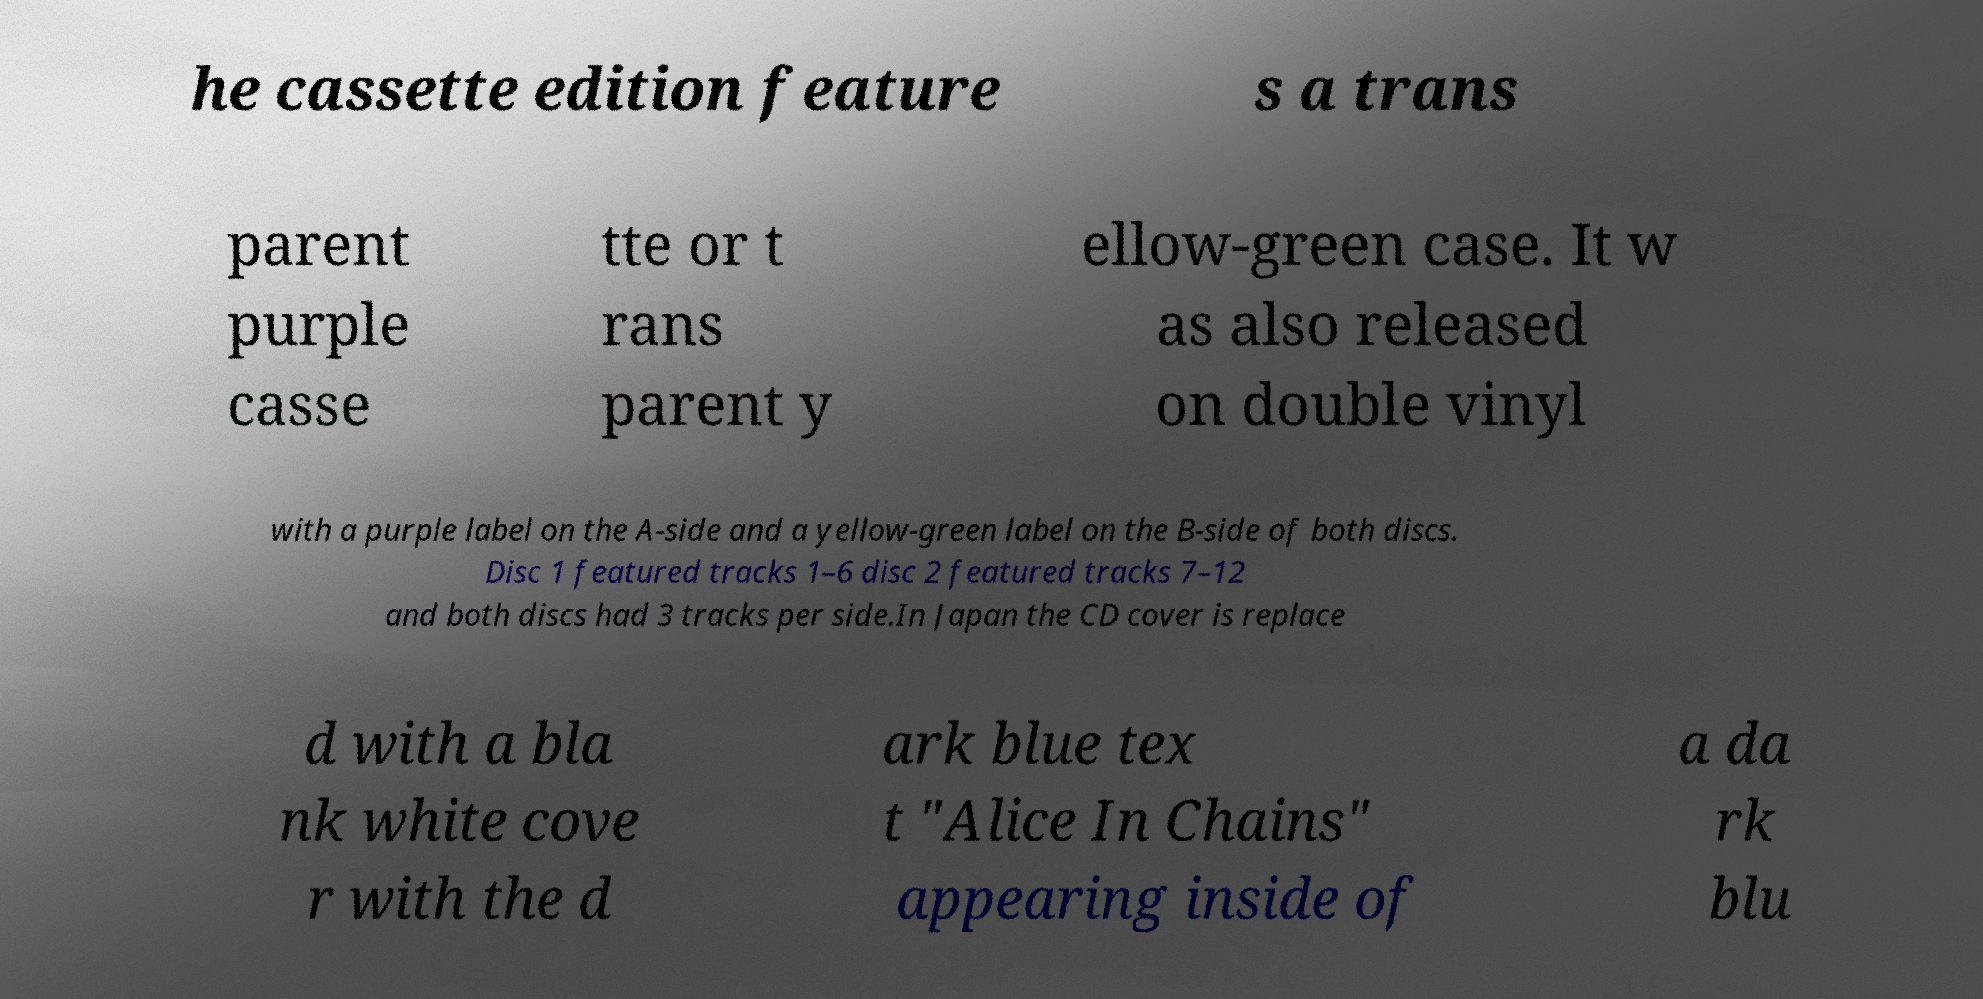Can you accurately transcribe the text from the provided image for me? he cassette edition feature s a trans parent purple casse tte or t rans parent y ellow-green case. It w as also released on double vinyl with a purple label on the A-side and a yellow-green label on the B-side of both discs. Disc 1 featured tracks 1–6 disc 2 featured tracks 7–12 and both discs had 3 tracks per side.In Japan the CD cover is replace d with a bla nk white cove r with the d ark blue tex t "Alice In Chains" appearing inside of a da rk blu 